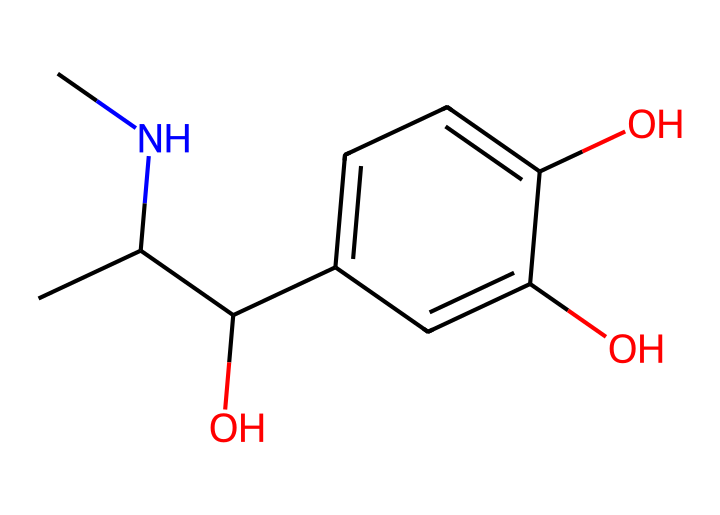What is the molecular formula of this chemical? The SMILES representation can be translated into a molecular formula by counting each type of atom indicated. In the structure, the atoms include 9 carbons, 13 hydrogens, and 3 oxygens, which gives the molecular formula C9H13O3.
Answer: C9H13O3 How many hydroxyl (-OH) groups are present in this structure? By examining the chemical structure, we can identify the functional groups. In the provided SMILES, there are three oxygen atoms, two of which are part of hydroxyl groups connected to carbons. Therefore, there are 3 hydroxyl groups in total.
Answer: 3 What functional group is represented by the -OH in this chemical? The -OH group is characteristic of alcohols, which indicates that the molecule has alcoholic properties. This group is also involved in the flavor and stability of the hormone.
Answer: Alcohol What type of biological activity is this molecule most associated with? This chemical structure is known to represent adrenaline, which is primarily associated with the 'fight or flight' response during stress and combat situations.
Answer: Hormonal response Which atom is responsible for the basic lipophilic nature of this chemical? In the compound, carbon atoms contribute to the lipophilic nature of the molecule due to their hydrocarbon character, despite the presence of hydroxyl groups. As a result, the overall structure still retains some lipophilic qualities largely because of the carbon backbone.
Answer: Carbon How does the structure of this chemical relate to its role as a neurotransmitter? The arrangement of carbon and hydroxyl groups in the molecule allows it to interact with receptors in the nervous system, making it effective as a neurotransmitter. The combination of its hydrophilic (due to hydroxyl groups) and lipophilic (due to carbon structure) regions facilitates its ability to cross membranes and bind to receptors.
Answer: Neurotransmitter 